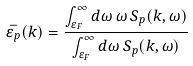<formula> <loc_0><loc_0><loc_500><loc_500>\bar { \varepsilon _ { p } } ( k ) = \frac { \int _ { \varepsilon _ { F } } ^ { \infty } d \omega \, \omega \, S _ { p } ( k , \omega ) } { \int _ { \varepsilon _ { F } } ^ { \infty } d \omega \, S _ { p } ( k , \omega ) } \,</formula> 